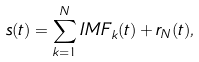<formula> <loc_0><loc_0><loc_500><loc_500>s ( t ) = \sum ^ { N } _ { k = 1 } I M F _ { k } ( t ) + r _ { N } ( t ) ,</formula> 